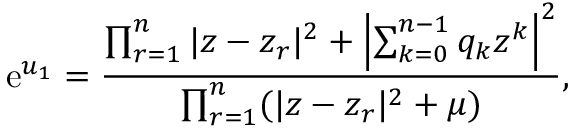Convert formula to latex. <formula><loc_0><loc_0><loc_500><loc_500>e ^ { u _ { 1 } } = { \frac { \prod _ { r = 1 } ^ { n } | z - z _ { r } | ^ { 2 } + \left | \sum _ { k = 0 } ^ { n - 1 } q _ { k } z ^ { k } \right | ^ { 2 } } { \prod _ { r = 1 } ^ { n } ( | z - z _ { r } | ^ { 2 } + \mu ) } } ,</formula> 